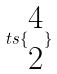<formula> <loc_0><loc_0><loc_500><loc_500>t s \{ \begin{matrix} 4 \\ 2 \end{matrix} \}</formula> 